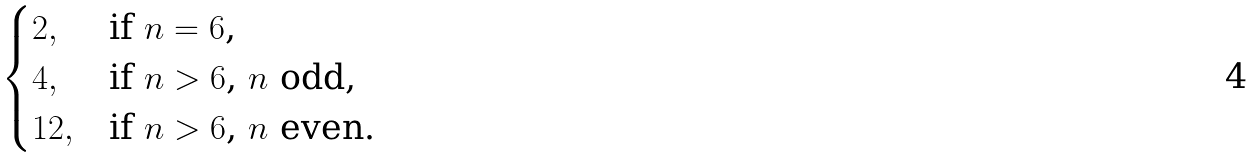<formula> <loc_0><loc_0><loc_500><loc_500>\begin{cases} 2 , & \text {if $n=6$,} \\ 4 , & \text {if $n>6$, $n$ odd,} \\ 1 2 , & \text {if $n>6$, $n$ even.} \end{cases}</formula> 